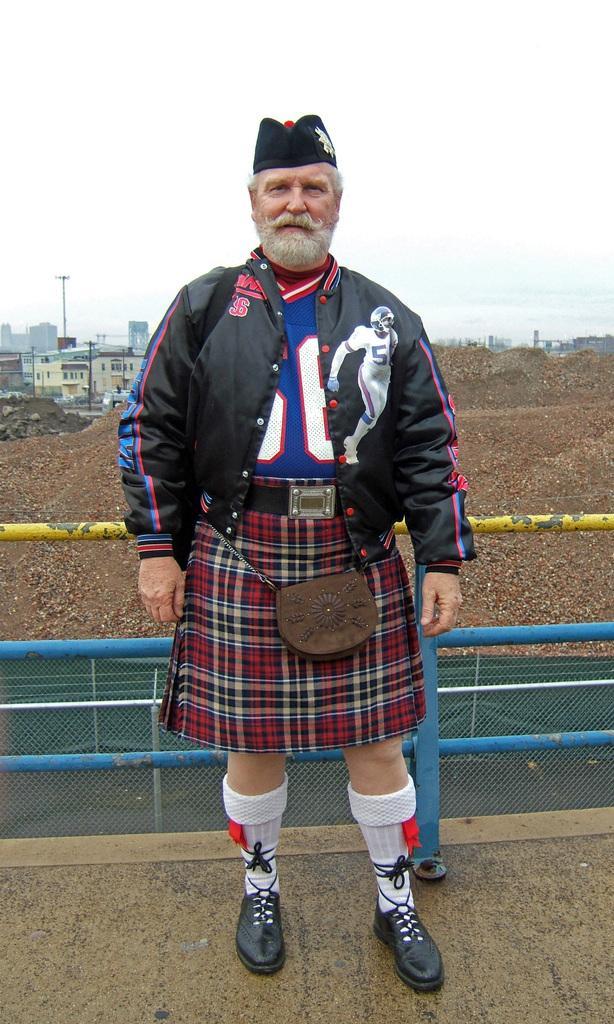Please provide a concise description of this image. In this image I can see a man is standing. I can see he is wearing black jacket, red skirt, black shoes, white colour socks and a black cap. I can also see he is carrying a bag. In the background I can see few buildings and few iron poles. 